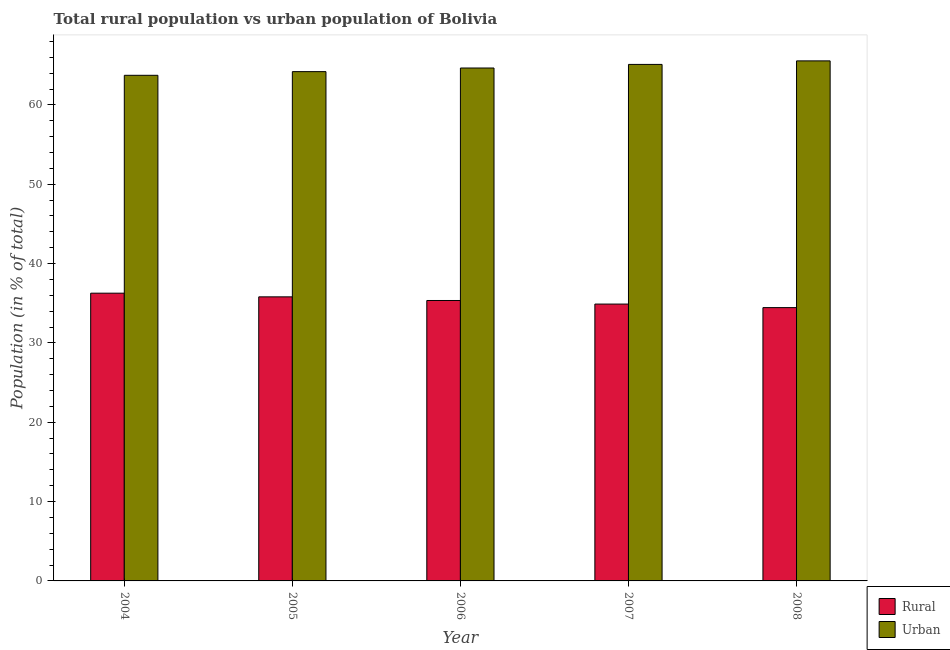How many different coloured bars are there?
Give a very brief answer. 2. How many groups of bars are there?
Make the answer very short. 5. Are the number of bars per tick equal to the number of legend labels?
Provide a short and direct response. Yes. How many bars are there on the 1st tick from the left?
Provide a succinct answer. 2. How many bars are there on the 2nd tick from the right?
Your response must be concise. 2. What is the label of the 1st group of bars from the left?
Provide a short and direct response. 2004. In how many cases, is the number of bars for a given year not equal to the number of legend labels?
Ensure brevity in your answer.  0. What is the rural population in 2008?
Provide a short and direct response. 34.45. Across all years, what is the maximum urban population?
Provide a short and direct response. 65.55. Across all years, what is the minimum urban population?
Ensure brevity in your answer.  63.73. In which year was the urban population maximum?
Provide a succinct answer. 2008. In which year was the rural population minimum?
Provide a succinct answer. 2008. What is the total urban population in the graph?
Keep it short and to the point. 323.23. What is the difference between the rural population in 2004 and that in 2005?
Ensure brevity in your answer.  0.46. What is the difference between the rural population in 2005 and the urban population in 2004?
Offer a terse response. -0.46. What is the average rural population per year?
Your answer should be compact. 35.35. In how many years, is the rural population greater than 8 %?
Give a very brief answer. 5. What is the ratio of the urban population in 2004 to that in 2007?
Make the answer very short. 0.98. Is the urban population in 2005 less than that in 2007?
Your response must be concise. Yes. Is the difference between the rural population in 2004 and 2007 greater than the difference between the urban population in 2004 and 2007?
Give a very brief answer. No. What is the difference between the highest and the second highest urban population?
Make the answer very short. 0.45. What is the difference between the highest and the lowest urban population?
Provide a succinct answer. 1.82. Is the sum of the rural population in 2006 and 2007 greater than the maximum urban population across all years?
Ensure brevity in your answer.  Yes. What does the 2nd bar from the left in 2006 represents?
Your answer should be compact. Urban. What does the 1st bar from the right in 2006 represents?
Ensure brevity in your answer.  Urban. Are all the bars in the graph horizontal?
Provide a short and direct response. No. How many years are there in the graph?
Keep it short and to the point. 5. Are the values on the major ticks of Y-axis written in scientific E-notation?
Your answer should be very brief. No. Does the graph contain any zero values?
Keep it short and to the point. No. What is the title of the graph?
Make the answer very short. Total rural population vs urban population of Bolivia. Does "Female" appear as one of the legend labels in the graph?
Your answer should be compact. No. What is the label or title of the Y-axis?
Your answer should be compact. Population (in % of total). What is the Population (in % of total) of Rural in 2004?
Give a very brief answer. 36.27. What is the Population (in % of total) in Urban in 2004?
Make the answer very short. 63.73. What is the Population (in % of total) in Rural in 2005?
Offer a terse response. 35.81. What is the Population (in % of total) of Urban in 2005?
Provide a succinct answer. 64.19. What is the Population (in % of total) of Rural in 2006?
Your answer should be compact. 35.35. What is the Population (in % of total) in Urban in 2006?
Your response must be concise. 64.65. What is the Population (in % of total) in Rural in 2007?
Your answer should be very brief. 34.9. What is the Population (in % of total) of Urban in 2007?
Your answer should be very brief. 65.1. What is the Population (in % of total) of Rural in 2008?
Your answer should be very brief. 34.45. What is the Population (in % of total) in Urban in 2008?
Offer a terse response. 65.55. Across all years, what is the maximum Population (in % of total) of Rural?
Provide a succinct answer. 36.27. Across all years, what is the maximum Population (in % of total) of Urban?
Ensure brevity in your answer.  65.55. Across all years, what is the minimum Population (in % of total) of Rural?
Give a very brief answer. 34.45. Across all years, what is the minimum Population (in % of total) in Urban?
Provide a succinct answer. 63.73. What is the total Population (in % of total) in Rural in the graph?
Make the answer very short. 176.77. What is the total Population (in % of total) of Urban in the graph?
Offer a terse response. 323.23. What is the difference between the Population (in % of total) in Rural in 2004 and that in 2005?
Your answer should be compact. 0.46. What is the difference between the Population (in % of total) in Urban in 2004 and that in 2005?
Make the answer very short. -0.46. What is the difference between the Population (in % of total) of Rural in 2004 and that in 2006?
Make the answer very short. 0.92. What is the difference between the Population (in % of total) in Urban in 2004 and that in 2006?
Make the answer very short. -0.92. What is the difference between the Population (in % of total) of Rural in 2004 and that in 2007?
Give a very brief answer. 1.37. What is the difference between the Population (in % of total) of Urban in 2004 and that in 2007?
Your answer should be compact. -1.37. What is the difference between the Population (in % of total) in Rural in 2004 and that in 2008?
Your answer should be compact. 1.82. What is the difference between the Population (in % of total) in Urban in 2004 and that in 2008?
Your response must be concise. -1.82. What is the difference between the Population (in % of total) of Rural in 2005 and that in 2006?
Provide a succinct answer. 0.46. What is the difference between the Population (in % of total) in Urban in 2005 and that in 2006?
Give a very brief answer. -0.46. What is the difference between the Population (in % of total) of Rural in 2005 and that in 2007?
Provide a succinct answer. 0.91. What is the difference between the Population (in % of total) in Urban in 2005 and that in 2007?
Make the answer very short. -0.91. What is the difference between the Population (in % of total) in Rural in 2005 and that in 2008?
Give a very brief answer. 1.36. What is the difference between the Population (in % of total) of Urban in 2005 and that in 2008?
Keep it short and to the point. -1.36. What is the difference between the Population (in % of total) in Rural in 2006 and that in 2007?
Offer a terse response. 0.45. What is the difference between the Population (in % of total) in Urban in 2006 and that in 2007?
Provide a succinct answer. -0.45. What is the difference between the Population (in % of total) of Rural in 2006 and that in 2008?
Make the answer very short. 0.9. What is the difference between the Population (in % of total) of Urban in 2006 and that in 2008?
Make the answer very short. -0.9. What is the difference between the Population (in % of total) of Rural in 2007 and that in 2008?
Offer a very short reply. 0.45. What is the difference between the Population (in % of total) of Urban in 2007 and that in 2008?
Your answer should be very brief. -0.45. What is the difference between the Population (in % of total) of Rural in 2004 and the Population (in % of total) of Urban in 2005?
Your response must be concise. -27.93. What is the difference between the Population (in % of total) of Rural in 2004 and the Population (in % of total) of Urban in 2006?
Your response must be concise. -28.38. What is the difference between the Population (in % of total) in Rural in 2004 and the Population (in % of total) in Urban in 2007?
Offer a terse response. -28.84. What is the difference between the Population (in % of total) of Rural in 2004 and the Population (in % of total) of Urban in 2008?
Give a very brief answer. -29.28. What is the difference between the Population (in % of total) in Rural in 2005 and the Population (in % of total) in Urban in 2006?
Ensure brevity in your answer.  -28.85. What is the difference between the Population (in % of total) of Rural in 2005 and the Population (in % of total) of Urban in 2007?
Offer a terse response. -29.3. What is the difference between the Population (in % of total) of Rural in 2005 and the Population (in % of total) of Urban in 2008?
Your answer should be compact. -29.74. What is the difference between the Population (in % of total) of Rural in 2006 and the Population (in % of total) of Urban in 2007?
Ensure brevity in your answer.  -29.76. What is the difference between the Population (in % of total) in Rural in 2006 and the Population (in % of total) in Urban in 2008?
Offer a terse response. -30.2. What is the difference between the Population (in % of total) in Rural in 2007 and the Population (in % of total) in Urban in 2008?
Offer a very short reply. -30.65. What is the average Population (in % of total) of Rural per year?
Offer a terse response. 35.35. What is the average Population (in % of total) of Urban per year?
Your answer should be very brief. 64.65. In the year 2004, what is the difference between the Population (in % of total) in Rural and Population (in % of total) in Urban?
Make the answer very short. -27.46. In the year 2005, what is the difference between the Population (in % of total) in Rural and Population (in % of total) in Urban?
Offer a terse response. -28.39. In the year 2006, what is the difference between the Population (in % of total) of Rural and Population (in % of total) of Urban?
Offer a very short reply. -29.3. In the year 2007, what is the difference between the Population (in % of total) in Rural and Population (in % of total) in Urban?
Provide a short and direct response. -30.21. In the year 2008, what is the difference between the Population (in % of total) of Rural and Population (in % of total) of Urban?
Make the answer very short. -31.1. What is the ratio of the Population (in % of total) of Rural in 2004 to that in 2005?
Offer a very short reply. 1.01. What is the ratio of the Population (in % of total) of Urban in 2004 to that in 2006?
Ensure brevity in your answer.  0.99. What is the ratio of the Population (in % of total) in Rural in 2004 to that in 2007?
Offer a very short reply. 1.04. What is the ratio of the Population (in % of total) in Urban in 2004 to that in 2007?
Provide a succinct answer. 0.98. What is the ratio of the Population (in % of total) in Rural in 2004 to that in 2008?
Keep it short and to the point. 1.05. What is the ratio of the Population (in % of total) of Urban in 2004 to that in 2008?
Your response must be concise. 0.97. What is the ratio of the Population (in % of total) of Urban in 2005 to that in 2006?
Ensure brevity in your answer.  0.99. What is the ratio of the Population (in % of total) of Rural in 2005 to that in 2007?
Your response must be concise. 1.03. What is the ratio of the Population (in % of total) of Urban in 2005 to that in 2007?
Give a very brief answer. 0.99. What is the ratio of the Population (in % of total) of Rural in 2005 to that in 2008?
Provide a short and direct response. 1.04. What is the ratio of the Population (in % of total) of Urban in 2005 to that in 2008?
Provide a succinct answer. 0.98. What is the ratio of the Population (in % of total) in Urban in 2006 to that in 2007?
Your answer should be compact. 0.99. What is the ratio of the Population (in % of total) of Rural in 2006 to that in 2008?
Offer a terse response. 1.03. What is the ratio of the Population (in % of total) in Urban in 2006 to that in 2008?
Your answer should be very brief. 0.99. What is the ratio of the Population (in % of total) of Rural in 2007 to that in 2008?
Your answer should be very brief. 1.01. What is the difference between the highest and the second highest Population (in % of total) in Rural?
Your answer should be compact. 0.46. What is the difference between the highest and the second highest Population (in % of total) of Urban?
Your answer should be very brief. 0.45. What is the difference between the highest and the lowest Population (in % of total) in Rural?
Your response must be concise. 1.82. What is the difference between the highest and the lowest Population (in % of total) in Urban?
Your response must be concise. 1.82. 